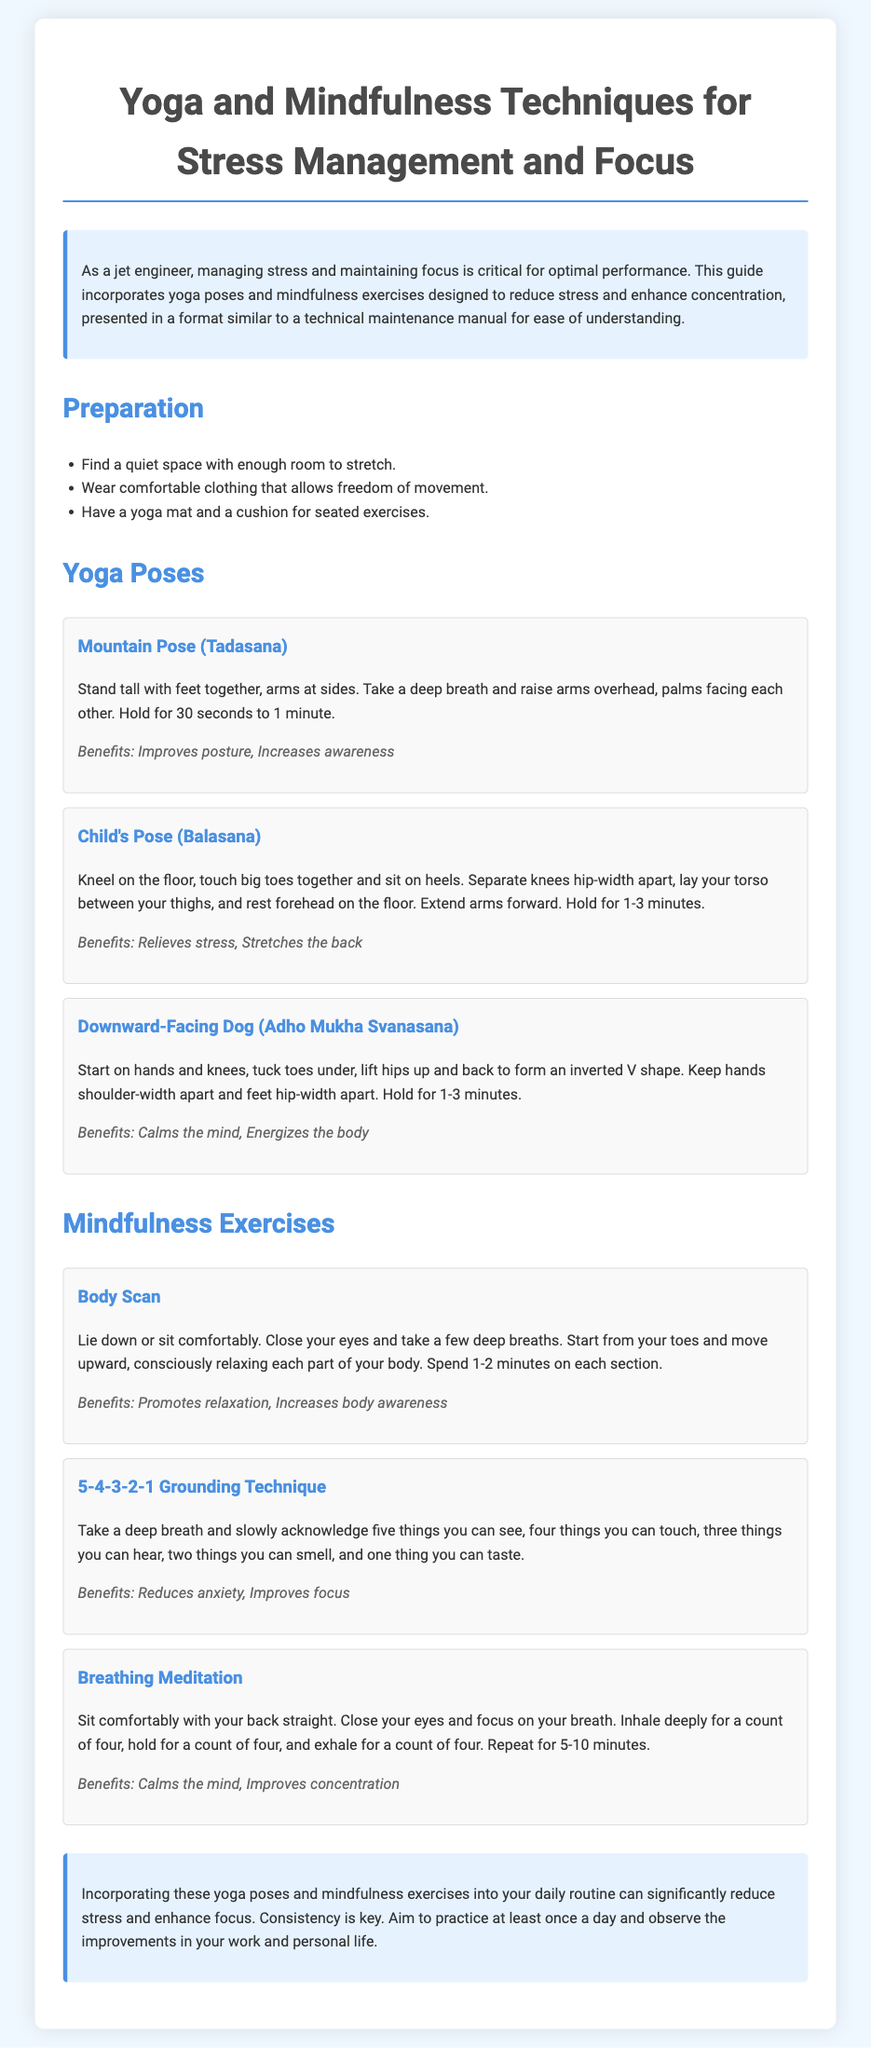What is the main purpose of this document? The document is a guide incorporating yoga poses and mindfulness exercises designed to reduce stress and enhance concentration for jet engineers.
Answer: Yoga and mindfulness techniques for stress management and focus How many yoga poses are described in the document? The document lists three specific yoga poses in the Yoga Poses section.
Answer: Three What is the first yoga pose mentioned? The first yoga pose listed in the document is Mountain Pose (Tadasana).
Answer: Mountain Pose (Tadasana) What mindfulness exercise requires acknowledging five senses? The mindfulness exercise that involves recognizing the five senses is called the 5-4-3-2-1 Grounding Technique.
Answer: 5-4-3-2-1 Grounding Technique What is a key benefit of the Child's Pose? The document states that one of the benefits of Child's Pose is relieving stress.
Answer: Relieves stress How long should the Breathing Meditation be practiced? The document recommends practicing Breathing Meditation for 5-10 minutes.
Answer: 5-10 minutes What should you aim for in your daily practice? The document advises aiming to practice at least once a day.
Answer: At least once a day What type of clothing should be worn during the exercises? The document suggests wearing comfortable clothing that allows freedom of movement.
Answer: Comfortable clothing 